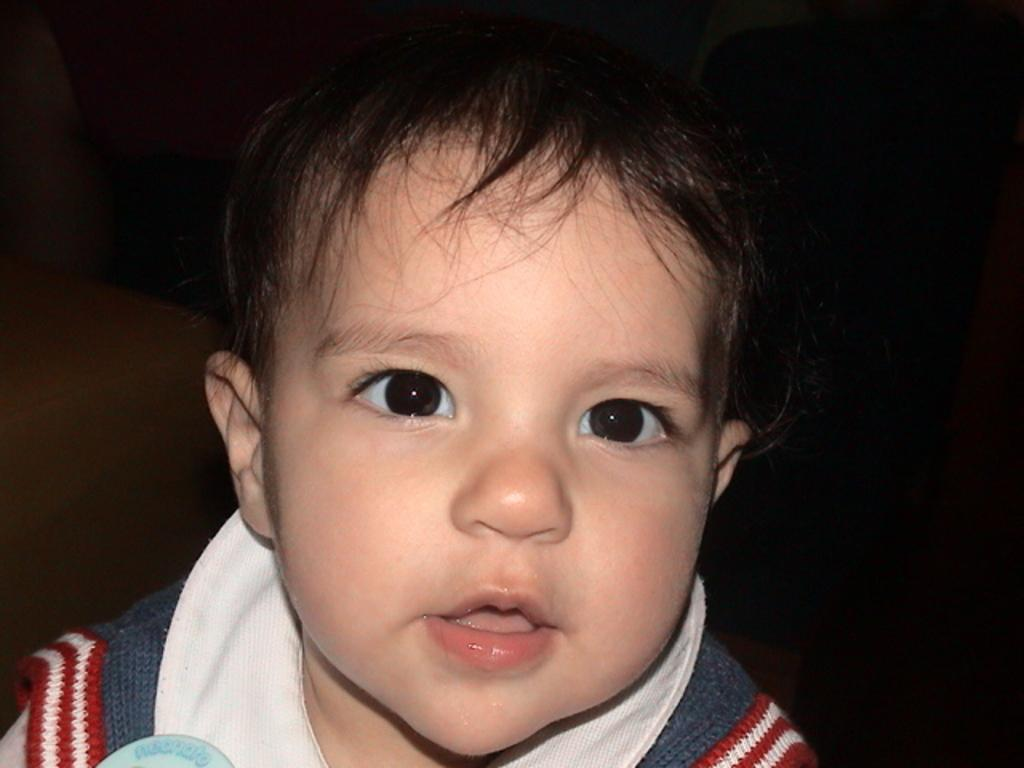What is the main subject of the image? The main subject of the image is a boy. What is the boy wearing in the image? The boy is wearing a shirt in the image. Can you describe the background of the image? The background of the image appears dark. What type of teeth can be seen in the image? There are no teeth visible in the image, as it features a boy and no reference to teeth. 